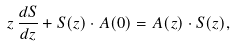Convert formula to latex. <formula><loc_0><loc_0><loc_500><loc_500>z \, \frac { d S } { d z } + S ( z ) \cdot A ( 0 ) = A ( z ) \cdot S ( z ) ,</formula> 